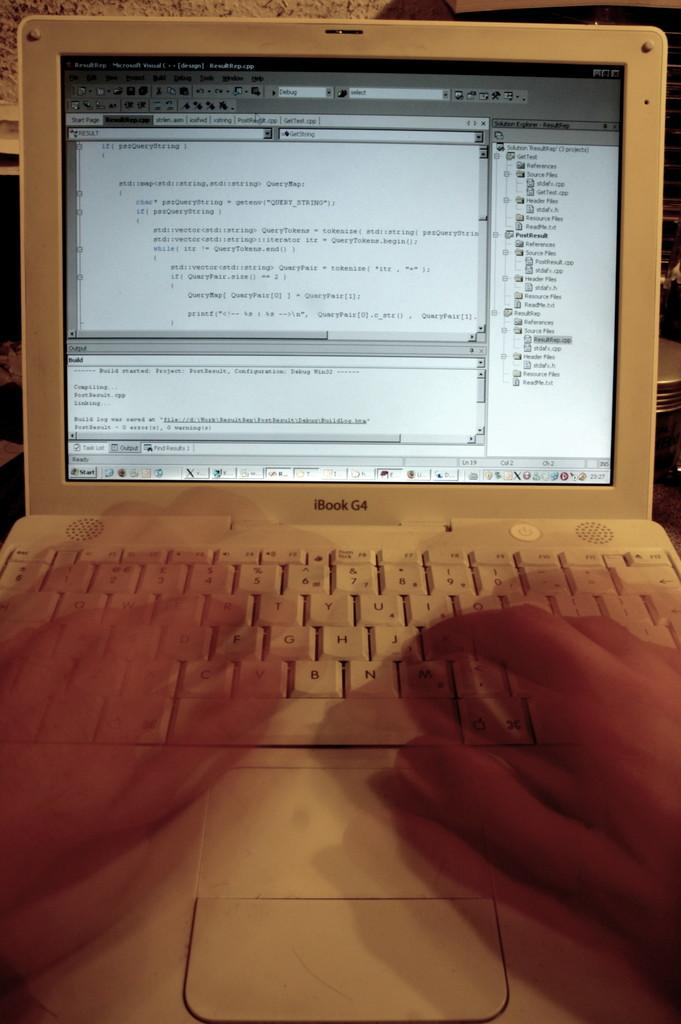What is the person in the image doing? The person in the image is working on a laptop. Can you describe the activity the person is engaged in? The person is working on a laptop, which suggests they might be typing, reading, or browsing the internet. What can be seen in the background of the image? There are objects in the background of the image, but their specific nature is not mentioned in the facts. How many friends does the person have in the image? The provided facts do not mention any friends or social interactions in the image, so it is impossible to determine the number of friends the person has. 